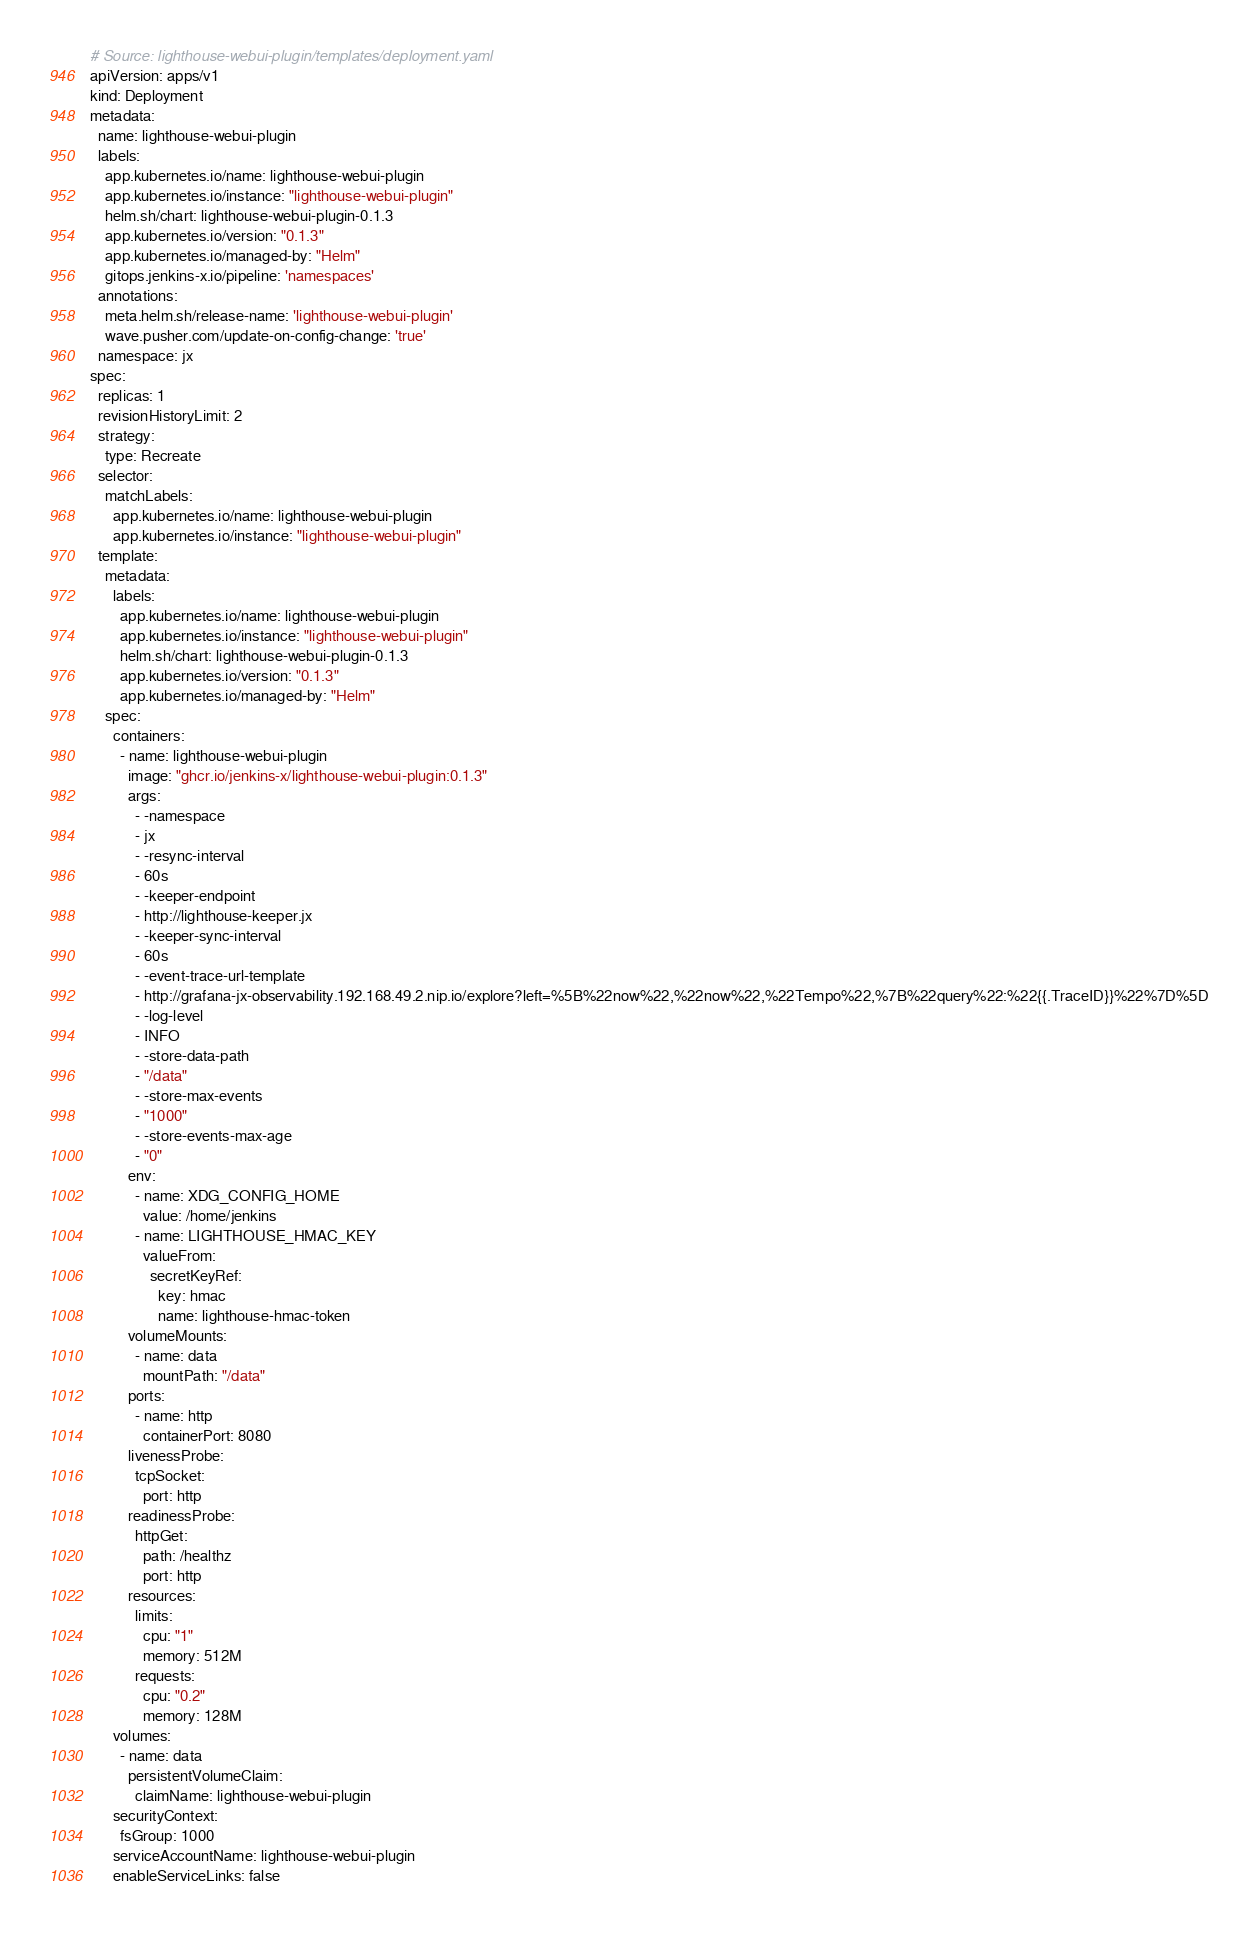<code> <loc_0><loc_0><loc_500><loc_500><_YAML_># Source: lighthouse-webui-plugin/templates/deployment.yaml
apiVersion: apps/v1
kind: Deployment
metadata:
  name: lighthouse-webui-plugin
  labels:
    app.kubernetes.io/name: lighthouse-webui-plugin
    app.kubernetes.io/instance: "lighthouse-webui-plugin"
    helm.sh/chart: lighthouse-webui-plugin-0.1.3
    app.kubernetes.io/version: "0.1.3"
    app.kubernetes.io/managed-by: "Helm"
    gitops.jenkins-x.io/pipeline: 'namespaces'
  annotations:
    meta.helm.sh/release-name: 'lighthouse-webui-plugin'
    wave.pusher.com/update-on-config-change: 'true'
  namespace: jx
spec:
  replicas: 1
  revisionHistoryLimit: 2
  strategy:
    type: Recreate
  selector:
    matchLabels:
      app.kubernetes.io/name: lighthouse-webui-plugin
      app.kubernetes.io/instance: "lighthouse-webui-plugin"
  template:
    metadata:
      labels:
        app.kubernetes.io/name: lighthouse-webui-plugin
        app.kubernetes.io/instance: "lighthouse-webui-plugin"
        helm.sh/chart: lighthouse-webui-plugin-0.1.3
        app.kubernetes.io/version: "0.1.3"
        app.kubernetes.io/managed-by: "Helm"
    spec:
      containers:
        - name: lighthouse-webui-plugin
          image: "ghcr.io/jenkins-x/lighthouse-webui-plugin:0.1.3"
          args:
            - -namespace
            - jx
            - -resync-interval
            - 60s
            - -keeper-endpoint
            - http://lighthouse-keeper.jx
            - -keeper-sync-interval
            - 60s
            - -event-trace-url-template
            - http://grafana-jx-observability.192.168.49.2.nip.io/explore?left=%5B%22now%22,%22now%22,%22Tempo%22,%7B%22query%22:%22{{.TraceID}}%22%7D%5D
            - -log-level
            - INFO
            - -store-data-path
            - "/data"
            - -store-max-events
            - "1000"
            - -store-events-max-age
            - "0"
          env:
            - name: XDG_CONFIG_HOME
              value: /home/jenkins
            - name: LIGHTHOUSE_HMAC_KEY
              valueFrom:
                secretKeyRef:
                  key: hmac
                  name: lighthouse-hmac-token
          volumeMounts:
            - name: data
              mountPath: "/data"
          ports:
            - name: http
              containerPort: 8080
          livenessProbe:
            tcpSocket:
              port: http
          readinessProbe:
            httpGet:
              path: /healthz
              port: http
          resources:
            limits:
              cpu: "1"
              memory: 512M
            requests:
              cpu: "0.2"
              memory: 128M
      volumes:
        - name: data
          persistentVolumeClaim:
            claimName: lighthouse-webui-plugin
      securityContext:
        fsGroup: 1000
      serviceAccountName: lighthouse-webui-plugin
      enableServiceLinks: false
</code> 